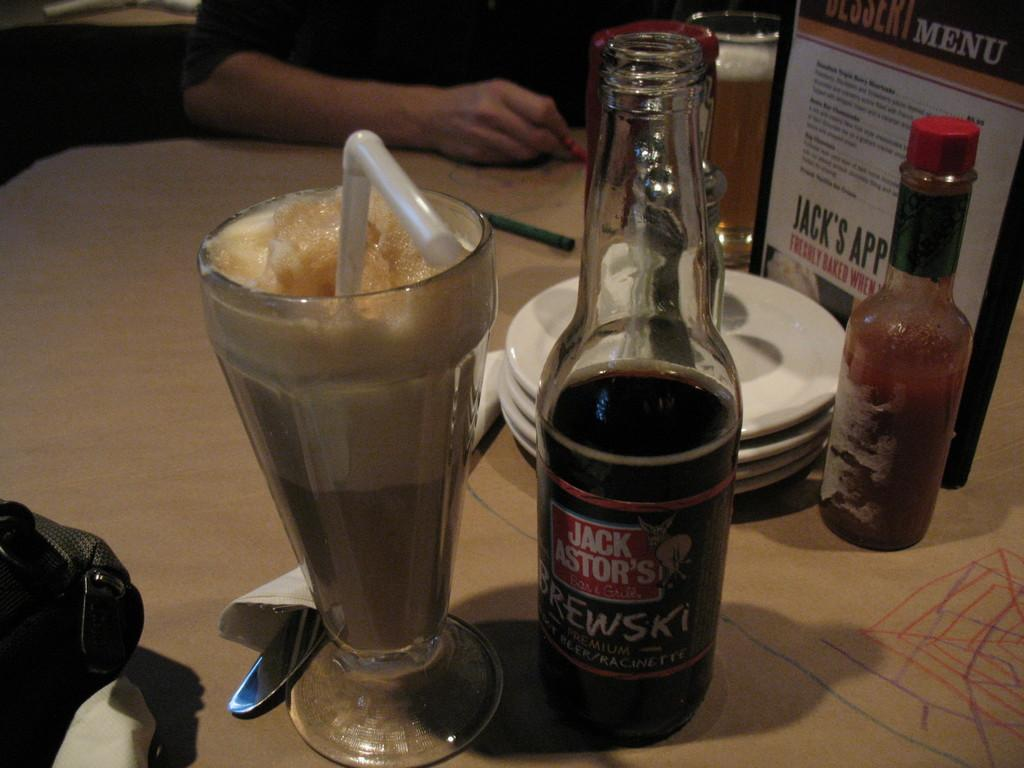<image>
Offer a succinct explanation of the picture presented. a JACK ASTOR'S BREWSKI half empty beer bottle with a root beer float and tobasco sauce bottle next to it. 